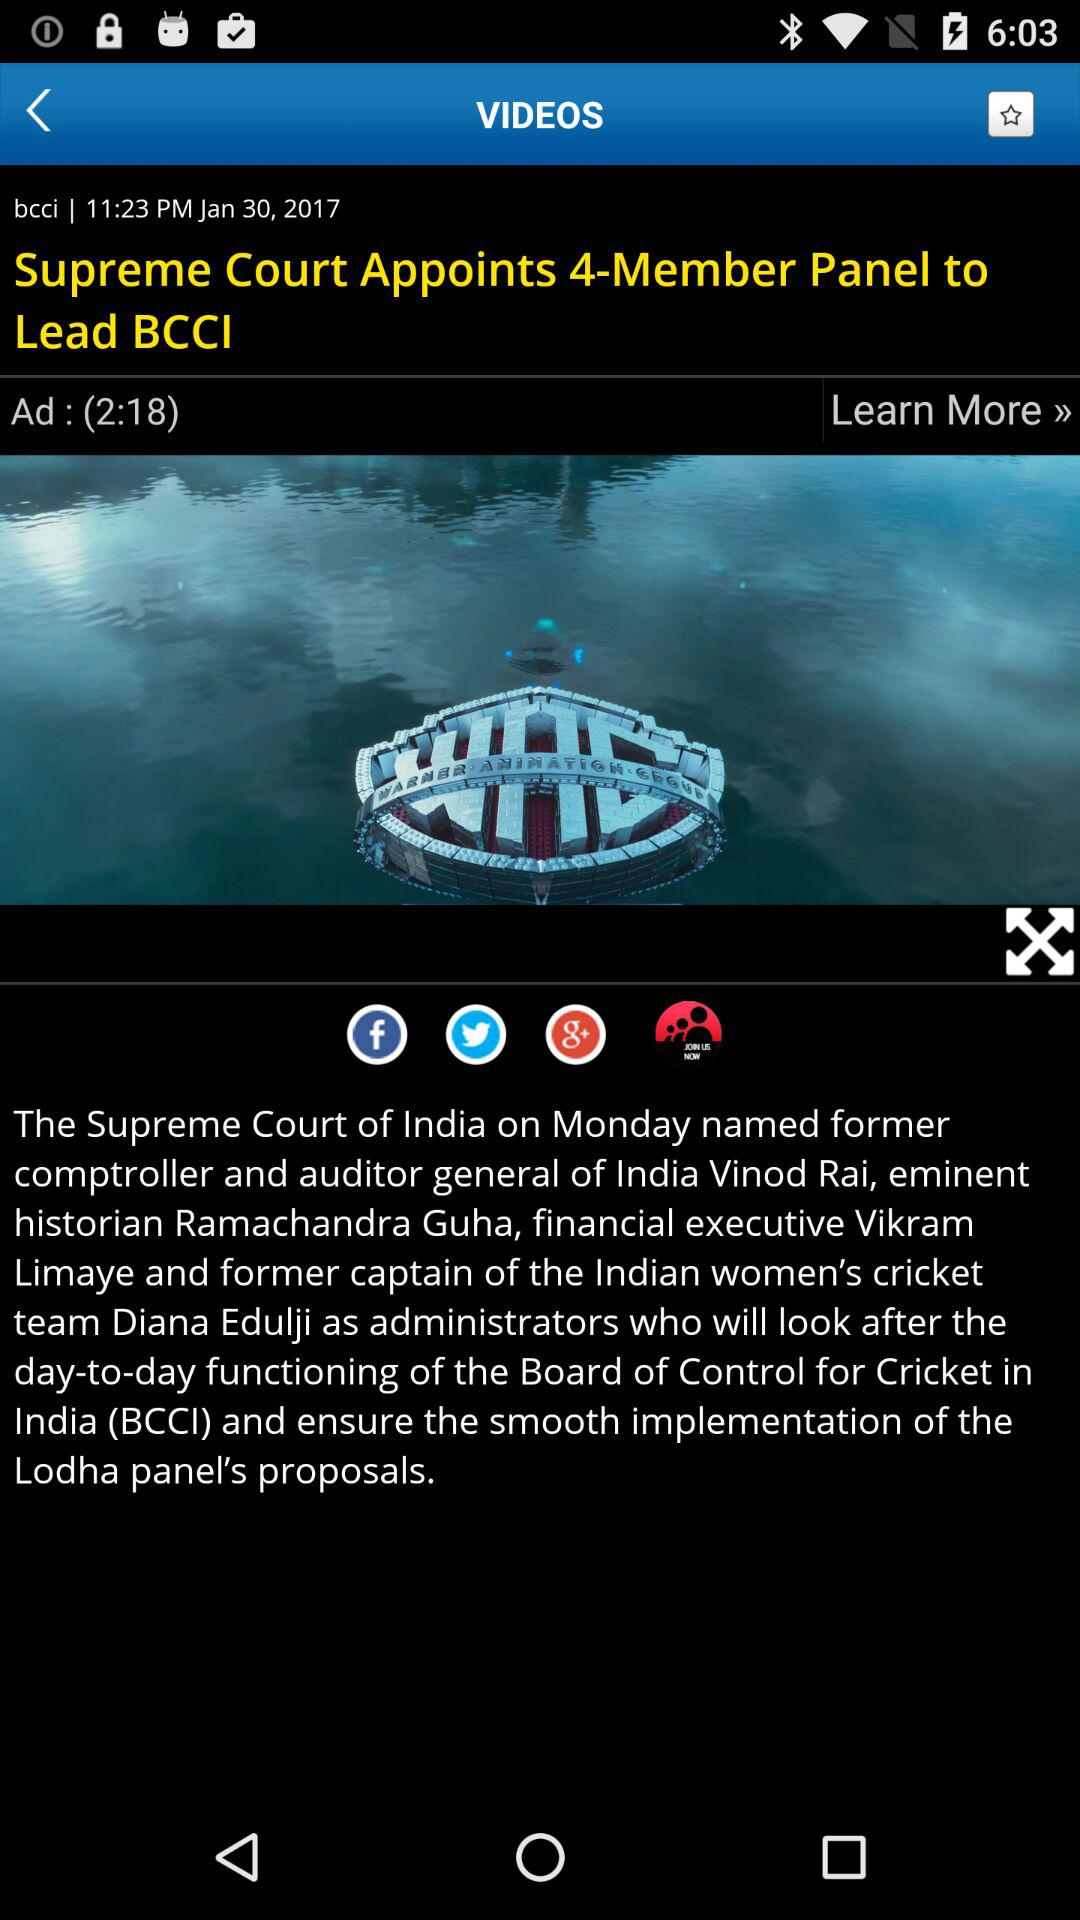Who is Vinod Rai? Vinod Rai is a former comptroller and auditor general of India. 